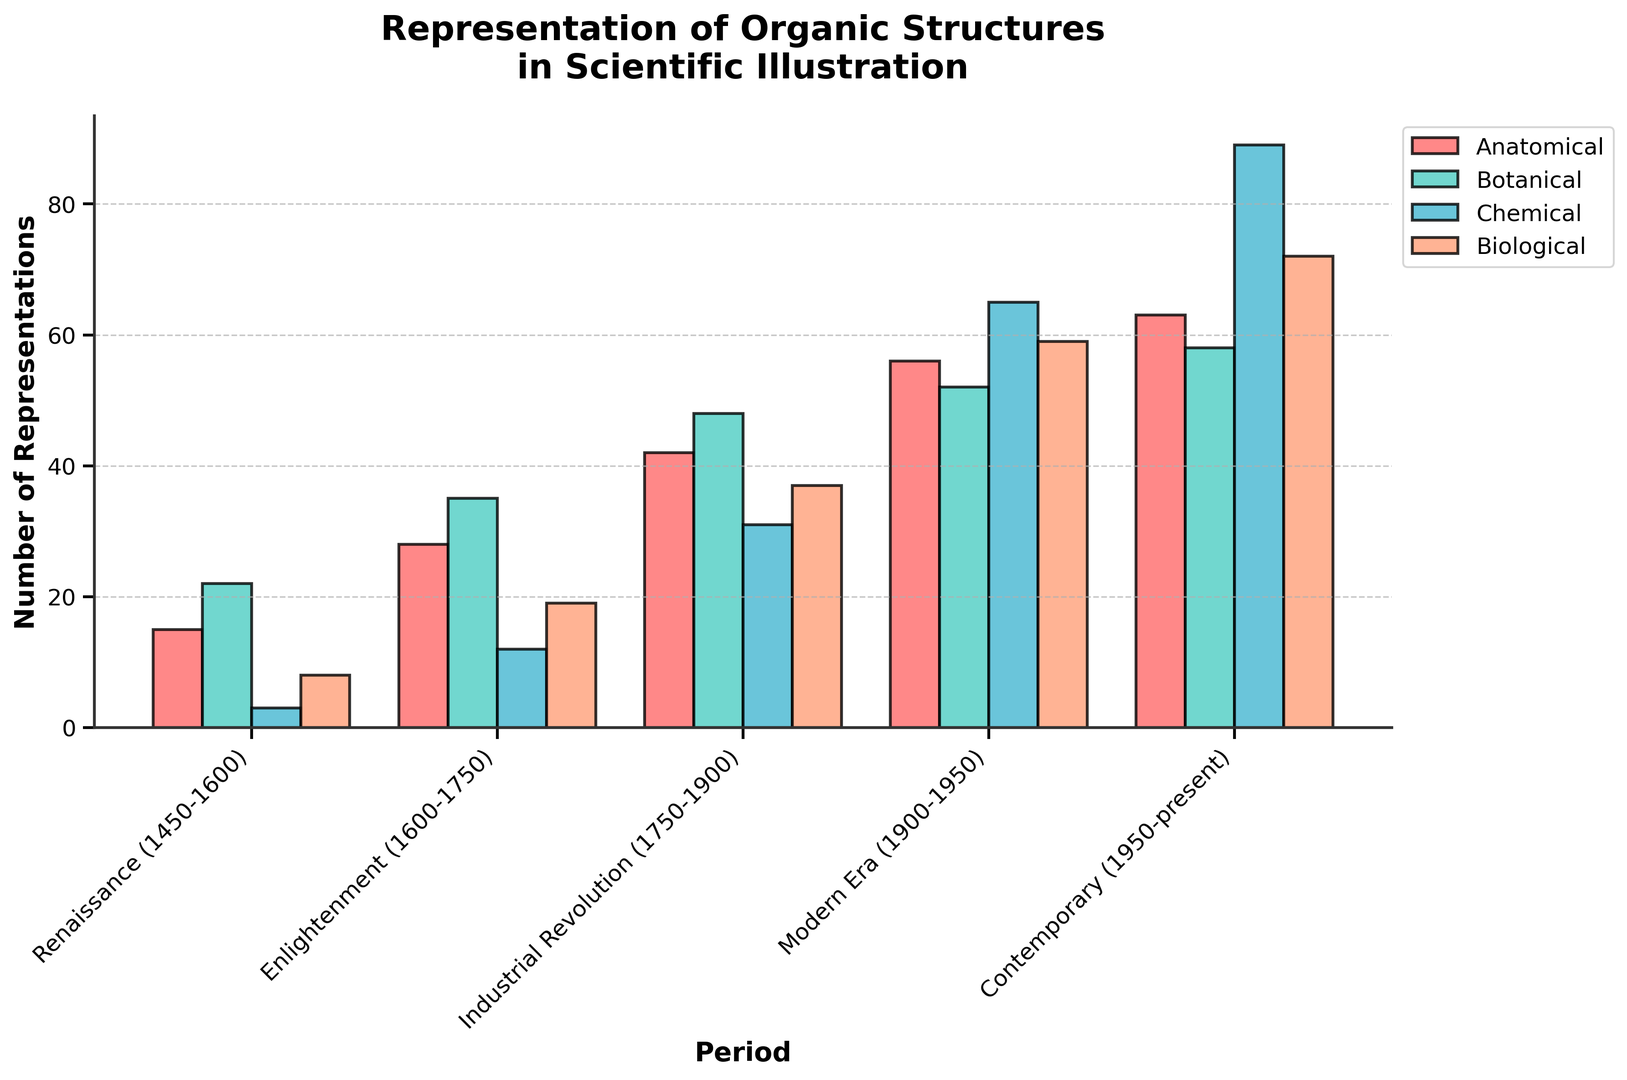What period had the highest number of chemical representations? By examining the tallest bar in the "Chemical" category, we see that Contemporary (1950-present) has the highest value.
Answer: Contemporary (1950-present) Which period has the lowest total number of representations across all categories? Summing the values for each period: Renaissance (1450-1600) is 48, Enlightenment (1600-1750) is 94, Industrial Revolution (1750-1900) is 158, Modern Era (1900-1950) is 232, Contemporary (1950-present) is 282. Therefore, the Renaissance has the lowest total.
Answer: Renaissance (1450-1600) How many more botanical illustrations were there in the Enlightenment period compared to the Renaissance period? Botanical illustrations in the Enlightenment period were 35, and in the Renaissance period, they were 22. Subtracting these values: 35 - 22 = 13.
Answer: 13 What is the average number of anatomical representations across all periods? Summing anatomical representations: 15 + 28 + 42 + 56 + 63 = 204. There are 5 periods, thus the average is 204 / 5 = 40.8.
Answer: 40.8 In which period did biological representations surpass botanical ones for the first time? Comparing the heights of the "Biological" and "Botanical" bars for each period, we see that in the Modern Era (1900-1950), Biological (59) surpasses Botanical (52) for the first time.
Answer: Modern Era (1900-1950) How does the number of botanical representations in the Contemporary period compare with the number in the Industrial Revolution? There are 58 botanical representations in the Contemporary period and 48 in the Industrial Revolution. 58 is greater than 48.
Answer: Greater What period had the smallest difference between botanical and anatomical representations? Calculating the differences for each period: Renaissance (7), Enlightenment (7), Industrial Revolution (6), Modern Era (4), Contemporary (5). The smallest difference is in the Modern Era (4).
Answer: Modern Era (1900-1950) How many total illustrations were represented in the Modern Era? Adding all categories in the Modern Era: 56 + 52 + 65 + 59 = 232.
Answer: 232 Which is the most visually dominant bar on the graph? The tallest and most visually dominant bar on the graph is the "Chemical" category in the Contemporary period.
Answer: Chemical in the Contemporary period What is the trend in anatomical representations from the Renaissance to the Contemporary period? Observing the "Anatomical" bars in chronological order: 15, 28, 42, 56, 63. There is a general increasing trend over time.
Answer: Increasing 